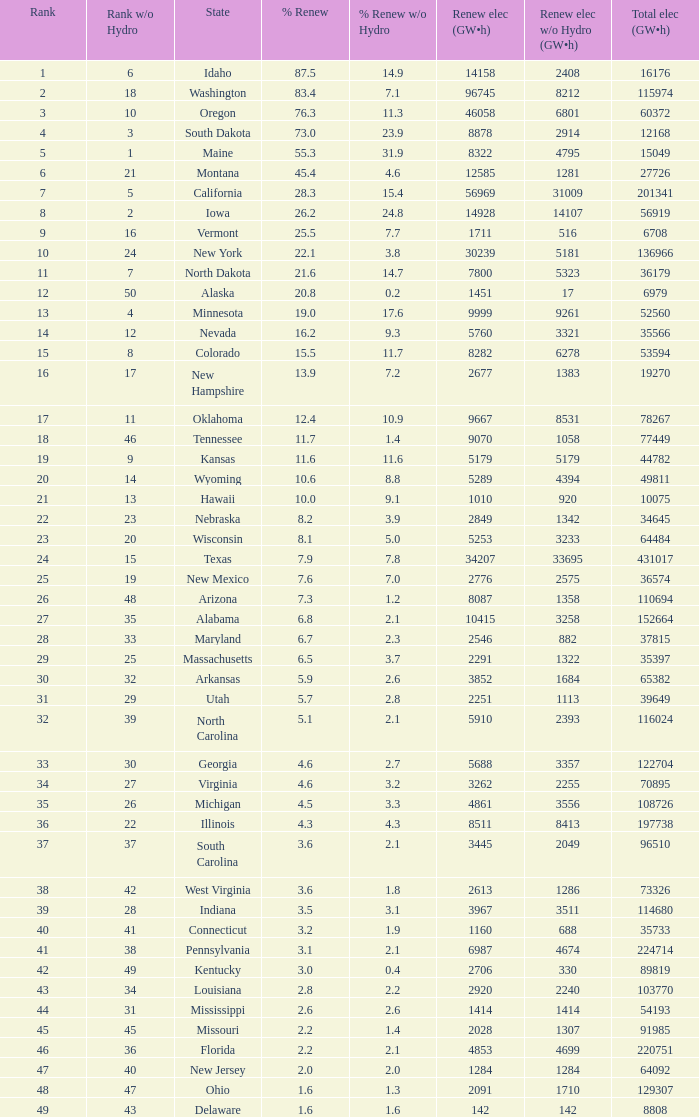What is the amount of renewable electricity without hydrogen power when the percentage of renewable energy is 83.4? 8212.0. 